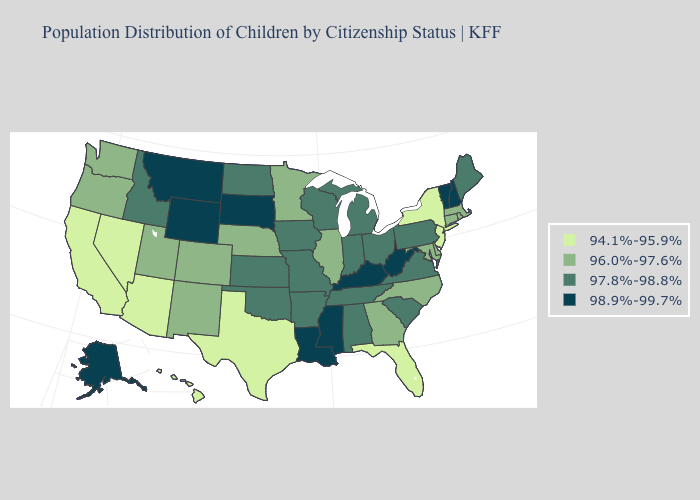What is the lowest value in the USA?
Short answer required. 94.1%-95.9%. Does the first symbol in the legend represent the smallest category?
Give a very brief answer. Yes. What is the value of Mississippi?
Answer briefly. 98.9%-99.7%. Does California have the lowest value in the USA?
Concise answer only. Yes. What is the value of Maryland?
Quick response, please. 96.0%-97.6%. What is the value of Tennessee?
Give a very brief answer. 97.8%-98.8%. What is the value of Ohio?
Give a very brief answer. 97.8%-98.8%. Does the map have missing data?
Quick response, please. No. Name the states that have a value in the range 96.0%-97.6%?
Write a very short answer. Colorado, Connecticut, Delaware, Georgia, Illinois, Maryland, Massachusetts, Minnesota, Nebraska, New Mexico, North Carolina, Oregon, Rhode Island, Utah, Washington. What is the value of Massachusetts?
Concise answer only. 96.0%-97.6%. Does Illinois have the lowest value in the MidWest?
Answer briefly. Yes. What is the value of Maine?
Concise answer only. 97.8%-98.8%. What is the value of Vermont?
Be succinct. 98.9%-99.7%. Which states hav the highest value in the South?
Quick response, please. Kentucky, Louisiana, Mississippi, West Virginia. 